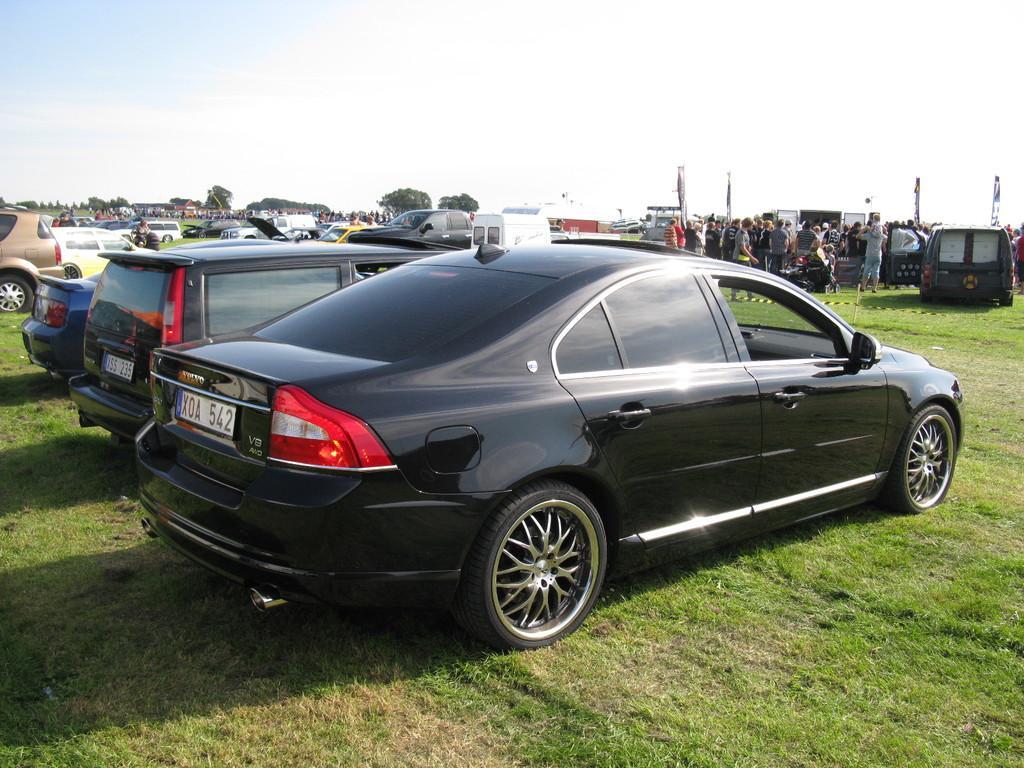Could you give a brief overview of what you see in this image? In this image we can see some vehicles and there are some people and we can see some trees and grass on the ground. At the top we can see the sky. 